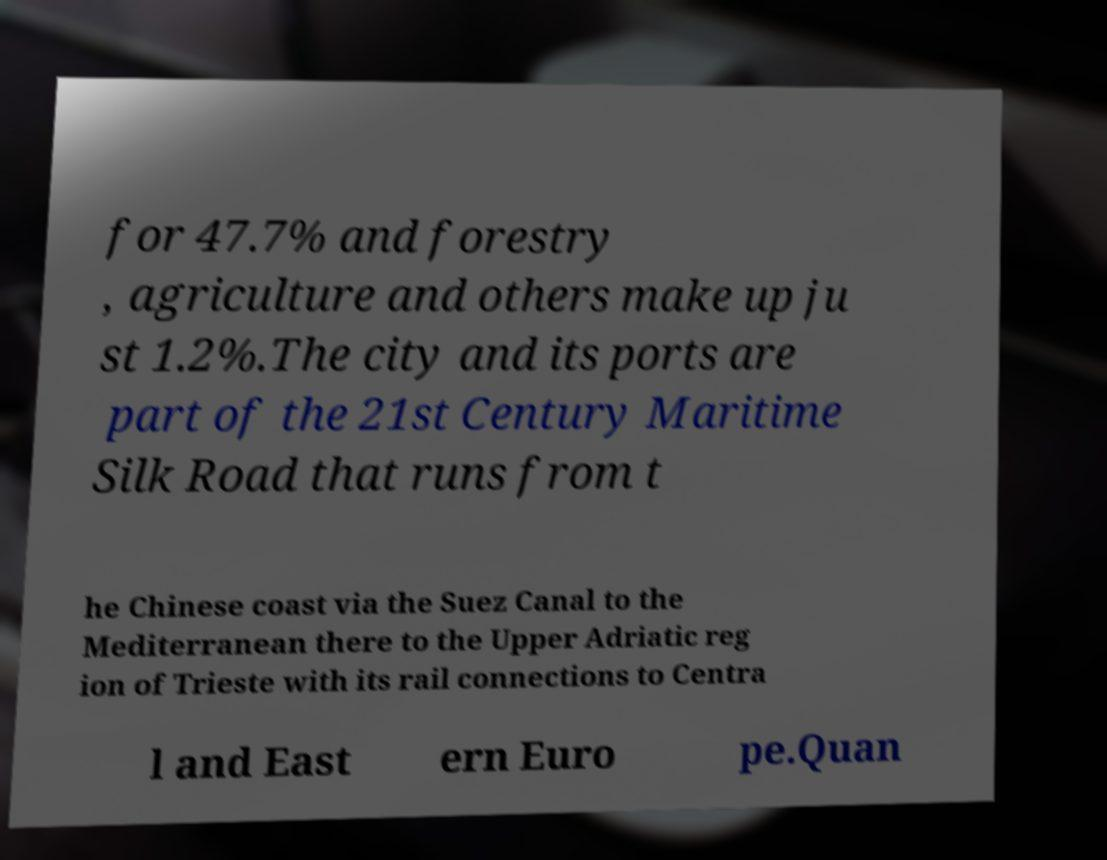What messages or text are displayed in this image? I need them in a readable, typed format. for 47.7% and forestry , agriculture and others make up ju st 1.2%.The city and its ports are part of the 21st Century Maritime Silk Road that runs from t he Chinese coast via the Suez Canal to the Mediterranean there to the Upper Adriatic reg ion of Trieste with its rail connections to Centra l and East ern Euro pe.Quan 